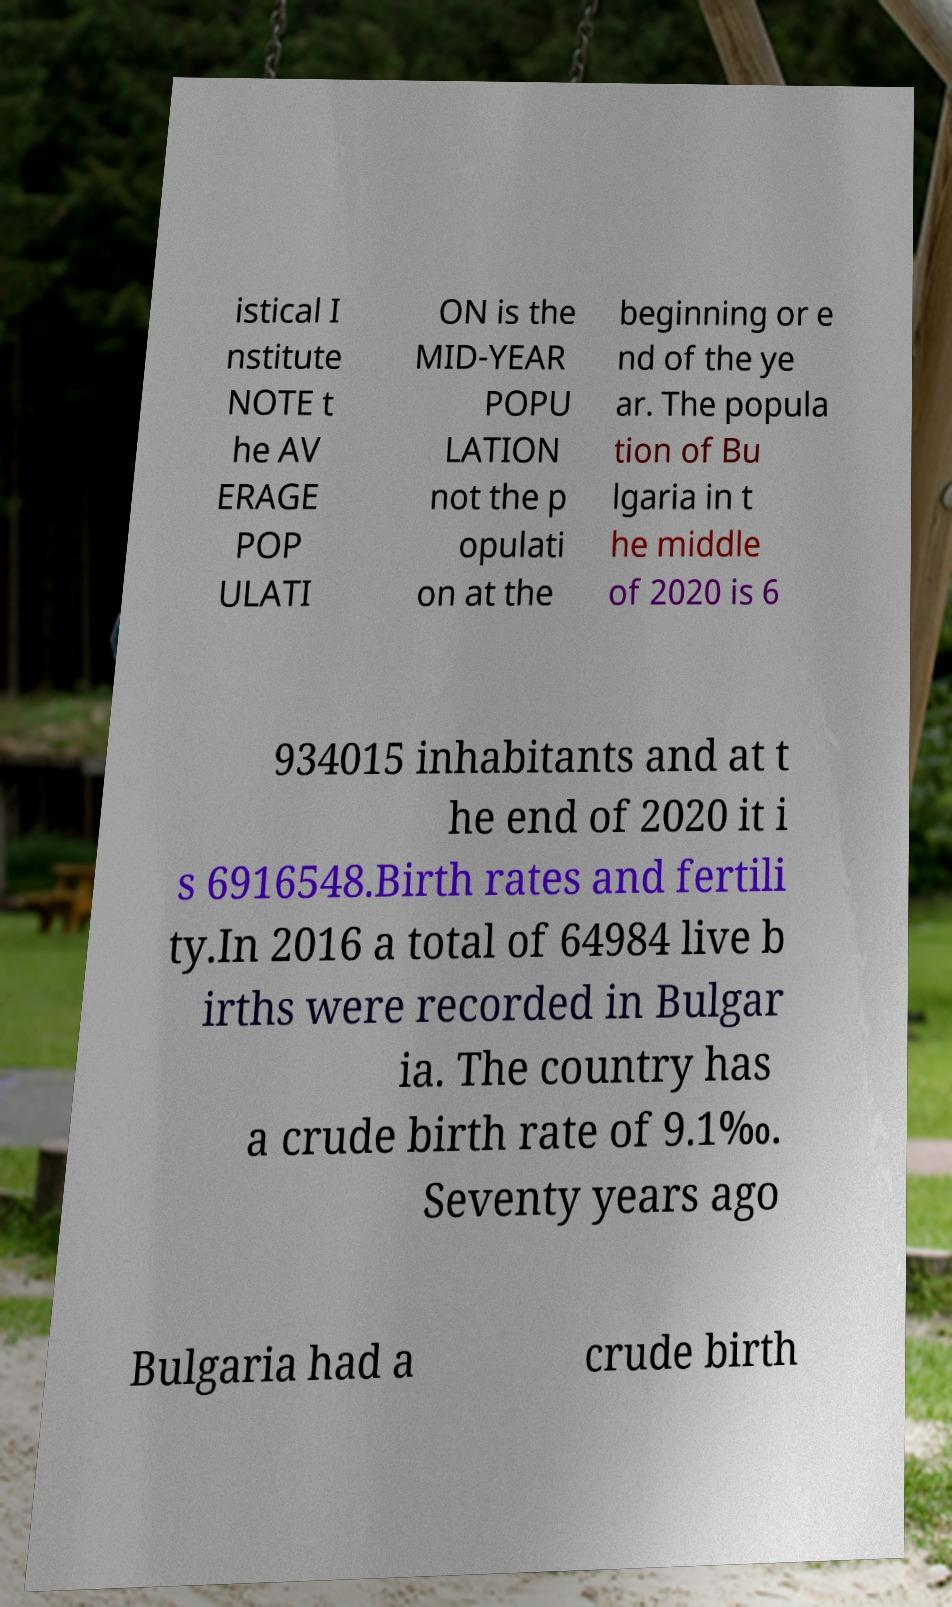Please identify and transcribe the text found in this image. istical I nstitute NOTE t he AV ERAGE POP ULATI ON is the MID-YEAR POPU LATION not the p opulati on at the beginning or e nd of the ye ar. The popula tion of Bu lgaria in t he middle of 2020 is 6 934015 inhabitants and at t he end of 2020 it i s 6916548.Birth rates and fertili ty.In 2016 a total of 64984 live b irths were recorded in Bulgar ia. The country has a crude birth rate of 9.1‰. Seventy years ago Bulgaria had a crude birth 